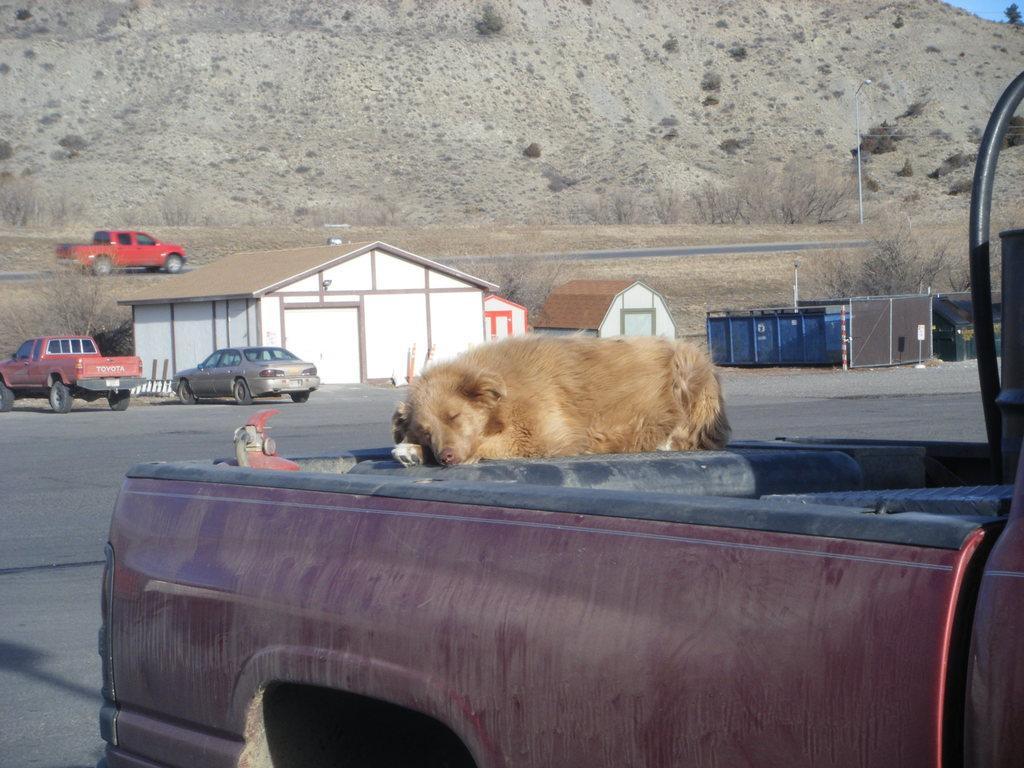Please provide a concise description of this image. In this image we can see an animal lying on the vehicle and we can also see houses, vehicles, grass and hill. 